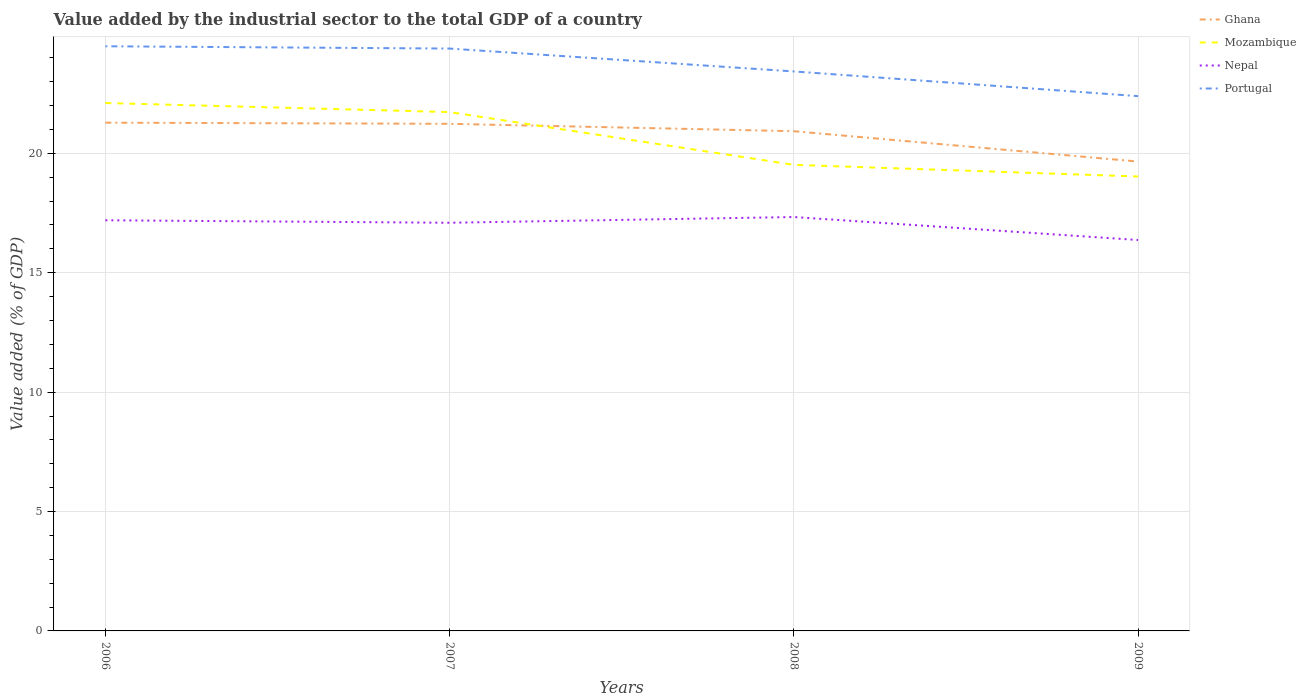Across all years, what is the maximum value added by the industrial sector to the total GDP in Mozambique?
Keep it short and to the point. 19.03. In which year was the value added by the industrial sector to the total GDP in Mozambique maximum?
Provide a succinct answer. 2009. What is the total value added by the industrial sector to the total GDP in Mozambique in the graph?
Your response must be concise. 2.7. What is the difference between the highest and the second highest value added by the industrial sector to the total GDP in Ghana?
Your answer should be very brief. 1.63. What is the difference between the highest and the lowest value added by the industrial sector to the total GDP in Portugal?
Your answer should be very brief. 2. What is the difference between two consecutive major ticks on the Y-axis?
Your answer should be compact. 5. Are the values on the major ticks of Y-axis written in scientific E-notation?
Your response must be concise. No. Does the graph contain any zero values?
Your answer should be very brief. No. How many legend labels are there?
Offer a very short reply. 4. What is the title of the graph?
Give a very brief answer. Value added by the industrial sector to the total GDP of a country. What is the label or title of the X-axis?
Give a very brief answer. Years. What is the label or title of the Y-axis?
Give a very brief answer. Value added (% of GDP). What is the Value added (% of GDP) of Ghana in 2006?
Ensure brevity in your answer.  21.29. What is the Value added (% of GDP) of Mozambique in 2006?
Provide a succinct answer. 22.11. What is the Value added (% of GDP) in Nepal in 2006?
Ensure brevity in your answer.  17.2. What is the Value added (% of GDP) of Portugal in 2006?
Give a very brief answer. 24.49. What is the Value added (% of GDP) in Ghana in 2007?
Offer a terse response. 21.24. What is the Value added (% of GDP) of Mozambique in 2007?
Make the answer very short. 21.73. What is the Value added (% of GDP) in Nepal in 2007?
Make the answer very short. 17.09. What is the Value added (% of GDP) in Portugal in 2007?
Make the answer very short. 24.39. What is the Value added (% of GDP) of Ghana in 2008?
Give a very brief answer. 20.93. What is the Value added (% of GDP) in Mozambique in 2008?
Offer a terse response. 19.52. What is the Value added (% of GDP) in Nepal in 2008?
Your answer should be compact. 17.33. What is the Value added (% of GDP) of Portugal in 2008?
Offer a terse response. 23.43. What is the Value added (% of GDP) in Ghana in 2009?
Make the answer very short. 19.66. What is the Value added (% of GDP) of Mozambique in 2009?
Offer a terse response. 19.03. What is the Value added (% of GDP) of Nepal in 2009?
Keep it short and to the point. 16.37. What is the Value added (% of GDP) in Portugal in 2009?
Offer a terse response. 22.4. Across all years, what is the maximum Value added (% of GDP) in Ghana?
Ensure brevity in your answer.  21.29. Across all years, what is the maximum Value added (% of GDP) in Mozambique?
Ensure brevity in your answer.  22.11. Across all years, what is the maximum Value added (% of GDP) of Nepal?
Your answer should be very brief. 17.33. Across all years, what is the maximum Value added (% of GDP) in Portugal?
Make the answer very short. 24.49. Across all years, what is the minimum Value added (% of GDP) in Ghana?
Provide a succinct answer. 19.66. Across all years, what is the minimum Value added (% of GDP) of Mozambique?
Make the answer very short. 19.03. Across all years, what is the minimum Value added (% of GDP) in Nepal?
Your answer should be compact. 16.37. Across all years, what is the minimum Value added (% of GDP) in Portugal?
Ensure brevity in your answer.  22.4. What is the total Value added (% of GDP) of Ghana in the graph?
Offer a terse response. 83.11. What is the total Value added (% of GDP) in Mozambique in the graph?
Provide a succinct answer. 82.39. What is the total Value added (% of GDP) in Nepal in the graph?
Make the answer very short. 68. What is the total Value added (% of GDP) of Portugal in the graph?
Your answer should be very brief. 94.7. What is the difference between the Value added (% of GDP) in Ghana in 2006 and that in 2007?
Keep it short and to the point. 0.05. What is the difference between the Value added (% of GDP) in Mozambique in 2006 and that in 2007?
Ensure brevity in your answer.  0.38. What is the difference between the Value added (% of GDP) in Nepal in 2006 and that in 2007?
Ensure brevity in your answer.  0.1. What is the difference between the Value added (% of GDP) of Portugal in 2006 and that in 2007?
Your answer should be compact. 0.1. What is the difference between the Value added (% of GDP) of Ghana in 2006 and that in 2008?
Your answer should be compact. 0.36. What is the difference between the Value added (% of GDP) in Mozambique in 2006 and that in 2008?
Keep it short and to the point. 2.59. What is the difference between the Value added (% of GDP) in Nepal in 2006 and that in 2008?
Your response must be concise. -0.14. What is the difference between the Value added (% of GDP) in Portugal in 2006 and that in 2008?
Make the answer very short. 1.05. What is the difference between the Value added (% of GDP) of Ghana in 2006 and that in 2009?
Keep it short and to the point. 1.63. What is the difference between the Value added (% of GDP) in Mozambique in 2006 and that in 2009?
Make the answer very short. 3.08. What is the difference between the Value added (% of GDP) in Nepal in 2006 and that in 2009?
Offer a terse response. 0.83. What is the difference between the Value added (% of GDP) of Portugal in 2006 and that in 2009?
Provide a short and direct response. 2.09. What is the difference between the Value added (% of GDP) in Ghana in 2007 and that in 2008?
Keep it short and to the point. 0.31. What is the difference between the Value added (% of GDP) of Mozambique in 2007 and that in 2008?
Ensure brevity in your answer.  2.21. What is the difference between the Value added (% of GDP) in Nepal in 2007 and that in 2008?
Your response must be concise. -0.24. What is the difference between the Value added (% of GDP) of Portugal in 2007 and that in 2008?
Offer a very short reply. 0.96. What is the difference between the Value added (% of GDP) in Ghana in 2007 and that in 2009?
Your response must be concise. 1.58. What is the difference between the Value added (% of GDP) of Mozambique in 2007 and that in 2009?
Make the answer very short. 2.7. What is the difference between the Value added (% of GDP) of Nepal in 2007 and that in 2009?
Offer a very short reply. 0.72. What is the difference between the Value added (% of GDP) in Portugal in 2007 and that in 2009?
Provide a short and direct response. 1.99. What is the difference between the Value added (% of GDP) of Ghana in 2008 and that in 2009?
Provide a short and direct response. 1.27. What is the difference between the Value added (% of GDP) in Mozambique in 2008 and that in 2009?
Give a very brief answer. 0.49. What is the difference between the Value added (% of GDP) in Nepal in 2008 and that in 2009?
Provide a short and direct response. 0.96. What is the difference between the Value added (% of GDP) in Portugal in 2008 and that in 2009?
Your answer should be very brief. 1.03. What is the difference between the Value added (% of GDP) of Ghana in 2006 and the Value added (% of GDP) of Mozambique in 2007?
Your answer should be very brief. -0.44. What is the difference between the Value added (% of GDP) in Ghana in 2006 and the Value added (% of GDP) in Nepal in 2007?
Make the answer very short. 4.19. What is the difference between the Value added (% of GDP) in Ghana in 2006 and the Value added (% of GDP) in Portugal in 2007?
Offer a very short reply. -3.1. What is the difference between the Value added (% of GDP) in Mozambique in 2006 and the Value added (% of GDP) in Nepal in 2007?
Your response must be concise. 5.01. What is the difference between the Value added (% of GDP) in Mozambique in 2006 and the Value added (% of GDP) in Portugal in 2007?
Provide a succinct answer. -2.28. What is the difference between the Value added (% of GDP) in Nepal in 2006 and the Value added (% of GDP) in Portugal in 2007?
Make the answer very short. -7.19. What is the difference between the Value added (% of GDP) in Ghana in 2006 and the Value added (% of GDP) in Mozambique in 2008?
Ensure brevity in your answer.  1.77. What is the difference between the Value added (% of GDP) in Ghana in 2006 and the Value added (% of GDP) in Nepal in 2008?
Your answer should be very brief. 3.95. What is the difference between the Value added (% of GDP) of Ghana in 2006 and the Value added (% of GDP) of Portugal in 2008?
Give a very brief answer. -2.15. What is the difference between the Value added (% of GDP) in Mozambique in 2006 and the Value added (% of GDP) in Nepal in 2008?
Give a very brief answer. 4.77. What is the difference between the Value added (% of GDP) of Mozambique in 2006 and the Value added (% of GDP) of Portugal in 2008?
Your answer should be compact. -1.32. What is the difference between the Value added (% of GDP) in Nepal in 2006 and the Value added (% of GDP) in Portugal in 2008?
Offer a very short reply. -6.23. What is the difference between the Value added (% of GDP) of Ghana in 2006 and the Value added (% of GDP) of Mozambique in 2009?
Make the answer very short. 2.25. What is the difference between the Value added (% of GDP) of Ghana in 2006 and the Value added (% of GDP) of Nepal in 2009?
Make the answer very short. 4.91. What is the difference between the Value added (% of GDP) of Ghana in 2006 and the Value added (% of GDP) of Portugal in 2009?
Offer a terse response. -1.11. What is the difference between the Value added (% of GDP) of Mozambique in 2006 and the Value added (% of GDP) of Nepal in 2009?
Make the answer very short. 5.74. What is the difference between the Value added (% of GDP) of Mozambique in 2006 and the Value added (% of GDP) of Portugal in 2009?
Keep it short and to the point. -0.29. What is the difference between the Value added (% of GDP) in Nepal in 2006 and the Value added (% of GDP) in Portugal in 2009?
Offer a terse response. -5.2. What is the difference between the Value added (% of GDP) in Ghana in 2007 and the Value added (% of GDP) in Mozambique in 2008?
Keep it short and to the point. 1.72. What is the difference between the Value added (% of GDP) in Ghana in 2007 and the Value added (% of GDP) in Nepal in 2008?
Your answer should be very brief. 3.9. What is the difference between the Value added (% of GDP) of Ghana in 2007 and the Value added (% of GDP) of Portugal in 2008?
Provide a short and direct response. -2.19. What is the difference between the Value added (% of GDP) in Mozambique in 2007 and the Value added (% of GDP) in Nepal in 2008?
Provide a short and direct response. 4.4. What is the difference between the Value added (% of GDP) of Mozambique in 2007 and the Value added (% of GDP) of Portugal in 2008?
Offer a terse response. -1.7. What is the difference between the Value added (% of GDP) in Nepal in 2007 and the Value added (% of GDP) in Portugal in 2008?
Offer a terse response. -6.34. What is the difference between the Value added (% of GDP) of Ghana in 2007 and the Value added (% of GDP) of Mozambique in 2009?
Give a very brief answer. 2.21. What is the difference between the Value added (% of GDP) of Ghana in 2007 and the Value added (% of GDP) of Nepal in 2009?
Offer a terse response. 4.87. What is the difference between the Value added (% of GDP) in Ghana in 2007 and the Value added (% of GDP) in Portugal in 2009?
Give a very brief answer. -1.16. What is the difference between the Value added (% of GDP) in Mozambique in 2007 and the Value added (% of GDP) in Nepal in 2009?
Your answer should be very brief. 5.36. What is the difference between the Value added (% of GDP) in Mozambique in 2007 and the Value added (% of GDP) in Portugal in 2009?
Offer a very short reply. -0.67. What is the difference between the Value added (% of GDP) in Nepal in 2007 and the Value added (% of GDP) in Portugal in 2009?
Provide a short and direct response. -5.3. What is the difference between the Value added (% of GDP) of Ghana in 2008 and the Value added (% of GDP) of Mozambique in 2009?
Ensure brevity in your answer.  1.9. What is the difference between the Value added (% of GDP) in Ghana in 2008 and the Value added (% of GDP) in Nepal in 2009?
Ensure brevity in your answer.  4.56. What is the difference between the Value added (% of GDP) of Ghana in 2008 and the Value added (% of GDP) of Portugal in 2009?
Provide a succinct answer. -1.47. What is the difference between the Value added (% of GDP) in Mozambique in 2008 and the Value added (% of GDP) in Nepal in 2009?
Offer a terse response. 3.15. What is the difference between the Value added (% of GDP) of Mozambique in 2008 and the Value added (% of GDP) of Portugal in 2009?
Offer a very short reply. -2.88. What is the difference between the Value added (% of GDP) in Nepal in 2008 and the Value added (% of GDP) in Portugal in 2009?
Provide a succinct answer. -5.06. What is the average Value added (% of GDP) in Ghana per year?
Your response must be concise. 20.78. What is the average Value added (% of GDP) in Mozambique per year?
Provide a short and direct response. 20.6. What is the average Value added (% of GDP) of Nepal per year?
Ensure brevity in your answer.  17. What is the average Value added (% of GDP) in Portugal per year?
Your response must be concise. 23.68. In the year 2006, what is the difference between the Value added (% of GDP) of Ghana and Value added (% of GDP) of Mozambique?
Your answer should be very brief. -0.82. In the year 2006, what is the difference between the Value added (% of GDP) of Ghana and Value added (% of GDP) of Nepal?
Offer a terse response. 4.09. In the year 2006, what is the difference between the Value added (% of GDP) of Ghana and Value added (% of GDP) of Portugal?
Your response must be concise. -3.2. In the year 2006, what is the difference between the Value added (% of GDP) in Mozambique and Value added (% of GDP) in Nepal?
Provide a succinct answer. 4.91. In the year 2006, what is the difference between the Value added (% of GDP) of Mozambique and Value added (% of GDP) of Portugal?
Provide a short and direct response. -2.38. In the year 2006, what is the difference between the Value added (% of GDP) in Nepal and Value added (% of GDP) in Portugal?
Make the answer very short. -7.29. In the year 2007, what is the difference between the Value added (% of GDP) of Ghana and Value added (% of GDP) of Mozambique?
Your answer should be very brief. -0.49. In the year 2007, what is the difference between the Value added (% of GDP) in Ghana and Value added (% of GDP) in Nepal?
Offer a very short reply. 4.14. In the year 2007, what is the difference between the Value added (% of GDP) of Ghana and Value added (% of GDP) of Portugal?
Offer a terse response. -3.15. In the year 2007, what is the difference between the Value added (% of GDP) of Mozambique and Value added (% of GDP) of Nepal?
Ensure brevity in your answer.  4.64. In the year 2007, what is the difference between the Value added (% of GDP) of Mozambique and Value added (% of GDP) of Portugal?
Offer a terse response. -2.66. In the year 2007, what is the difference between the Value added (% of GDP) in Nepal and Value added (% of GDP) in Portugal?
Provide a succinct answer. -7.29. In the year 2008, what is the difference between the Value added (% of GDP) in Ghana and Value added (% of GDP) in Mozambique?
Your answer should be very brief. 1.41. In the year 2008, what is the difference between the Value added (% of GDP) of Ghana and Value added (% of GDP) of Nepal?
Your response must be concise. 3.59. In the year 2008, what is the difference between the Value added (% of GDP) in Ghana and Value added (% of GDP) in Portugal?
Ensure brevity in your answer.  -2.5. In the year 2008, what is the difference between the Value added (% of GDP) of Mozambique and Value added (% of GDP) of Nepal?
Give a very brief answer. 2.19. In the year 2008, what is the difference between the Value added (% of GDP) of Mozambique and Value added (% of GDP) of Portugal?
Offer a terse response. -3.91. In the year 2008, what is the difference between the Value added (% of GDP) in Nepal and Value added (% of GDP) in Portugal?
Your response must be concise. -6.1. In the year 2009, what is the difference between the Value added (% of GDP) of Ghana and Value added (% of GDP) of Mozambique?
Make the answer very short. 0.63. In the year 2009, what is the difference between the Value added (% of GDP) of Ghana and Value added (% of GDP) of Nepal?
Your answer should be compact. 3.29. In the year 2009, what is the difference between the Value added (% of GDP) of Ghana and Value added (% of GDP) of Portugal?
Offer a terse response. -2.74. In the year 2009, what is the difference between the Value added (% of GDP) of Mozambique and Value added (% of GDP) of Nepal?
Provide a short and direct response. 2.66. In the year 2009, what is the difference between the Value added (% of GDP) of Mozambique and Value added (% of GDP) of Portugal?
Your answer should be compact. -3.37. In the year 2009, what is the difference between the Value added (% of GDP) in Nepal and Value added (% of GDP) in Portugal?
Your response must be concise. -6.03. What is the ratio of the Value added (% of GDP) of Mozambique in 2006 to that in 2007?
Offer a terse response. 1.02. What is the ratio of the Value added (% of GDP) in Nepal in 2006 to that in 2007?
Offer a very short reply. 1.01. What is the ratio of the Value added (% of GDP) of Ghana in 2006 to that in 2008?
Offer a very short reply. 1.02. What is the ratio of the Value added (% of GDP) in Mozambique in 2006 to that in 2008?
Offer a very short reply. 1.13. What is the ratio of the Value added (% of GDP) in Nepal in 2006 to that in 2008?
Offer a terse response. 0.99. What is the ratio of the Value added (% of GDP) of Portugal in 2006 to that in 2008?
Your response must be concise. 1.04. What is the ratio of the Value added (% of GDP) in Ghana in 2006 to that in 2009?
Your response must be concise. 1.08. What is the ratio of the Value added (% of GDP) of Mozambique in 2006 to that in 2009?
Keep it short and to the point. 1.16. What is the ratio of the Value added (% of GDP) of Nepal in 2006 to that in 2009?
Your answer should be very brief. 1.05. What is the ratio of the Value added (% of GDP) of Portugal in 2006 to that in 2009?
Offer a very short reply. 1.09. What is the ratio of the Value added (% of GDP) in Ghana in 2007 to that in 2008?
Your answer should be compact. 1.01. What is the ratio of the Value added (% of GDP) in Mozambique in 2007 to that in 2008?
Ensure brevity in your answer.  1.11. What is the ratio of the Value added (% of GDP) in Nepal in 2007 to that in 2008?
Ensure brevity in your answer.  0.99. What is the ratio of the Value added (% of GDP) of Portugal in 2007 to that in 2008?
Offer a terse response. 1.04. What is the ratio of the Value added (% of GDP) of Ghana in 2007 to that in 2009?
Provide a succinct answer. 1.08. What is the ratio of the Value added (% of GDP) of Mozambique in 2007 to that in 2009?
Provide a short and direct response. 1.14. What is the ratio of the Value added (% of GDP) in Nepal in 2007 to that in 2009?
Provide a succinct answer. 1.04. What is the ratio of the Value added (% of GDP) of Portugal in 2007 to that in 2009?
Your answer should be very brief. 1.09. What is the ratio of the Value added (% of GDP) in Ghana in 2008 to that in 2009?
Ensure brevity in your answer.  1.06. What is the ratio of the Value added (% of GDP) of Mozambique in 2008 to that in 2009?
Your answer should be compact. 1.03. What is the ratio of the Value added (% of GDP) in Nepal in 2008 to that in 2009?
Ensure brevity in your answer.  1.06. What is the ratio of the Value added (% of GDP) in Portugal in 2008 to that in 2009?
Your response must be concise. 1.05. What is the difference between the highest and the second highest Value added (% of GDP) in Ghana?
Provide a short and direct response. 0.05. What is the difference between the highest and the second highest Value added (% of GDP) in Mozambique?
Make the answer very short. 0.38. What is the difference between the highest and the second highest Value added (% of GDP) of Nepal?
Provide a short and direct response. 0.14. What is the difference between the highest and the second highest Value added (% of GDP) of Portugal?
Your response must be concise. 0.1. What is the difference between the highest and the lowest Value added (% of GDP) in Ghana?
Offer a very short reply. 1.63. What is the difference between the highest and the lowest Value added (% of GDP) in Mozambique?
Give a very brief answer. 3.08. What is the difference between the highest and the lowest Value added (% of GDP) of Nepal?
Your response must be concise. 0.96. What is the difference between the highest and the lowest Value added (% of GDP) of Portugal?
Ensure brevity in your answer.  2.09. 